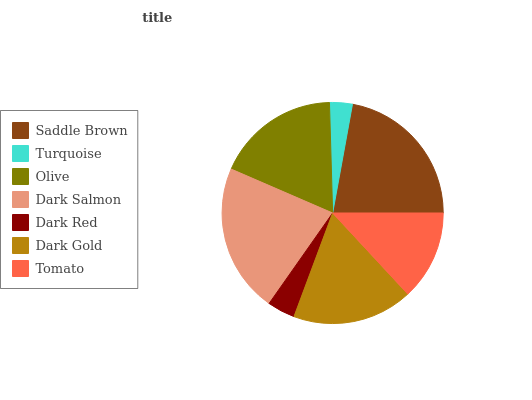Is Turquoise the minimum?
Answer yes or no. Yes. Is Saddle Brown the maximum?
Answer yes or no. Yes. Is Olive the minimum?
Answer yes or no. No. Is Olive the maximum?
Answer yes or no. No. Is Olive greater than Turquoise?
Answer yes or no. Yes. Is Turquoise less than Olive?
Answer yes or no. Yes. Is Turquoise greater than Olive?
Answer yes or no. No. Is Olive less than Turquoise?
Answer yes or no. No. Is Dark Gold the high median?
Answer yes or no. Yes. Is Dark Gold the low median?
Answer yes or no. Yes. Is Turquoise the high median?
Answer yes or no. No. Is Saddle Brown the low median?
Answer yes or no. No. 